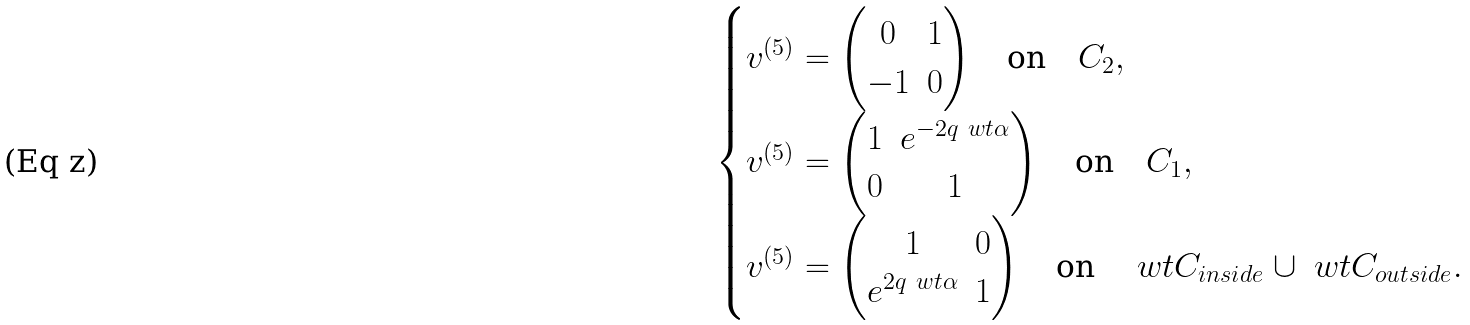Convert formula to latex. <formula><loc_0><loc_0><loc_500><loc_500>\begin{cases} v ^ { ( 5 ) } = \begin{pmatrix} 0 & 1 \\ - 1 & 0 \end{pmatrix} \quad \text {on} \quad C _ { 2 } , \\ v ^ { ( 5 ) } = \begin{pmatrix} 1 & e ^ { - 2 q \ w t { \alpha } } \\ 0 & 1 \end{pmatrix} \quad \text {on} \quad C _ { 1 } , \\ v ^ { ( 5 ) } = \begin{pmatrix} 1 & 0 \\ e ^ { 2 q \ w t { \alpha } } & 1 \end{pmatrix} \quad \text {on} \quad \ w t { C } _ { i n s i d e } \cup \ w t { C } _ { o u t s i d e } . \end{cases}</formula> 